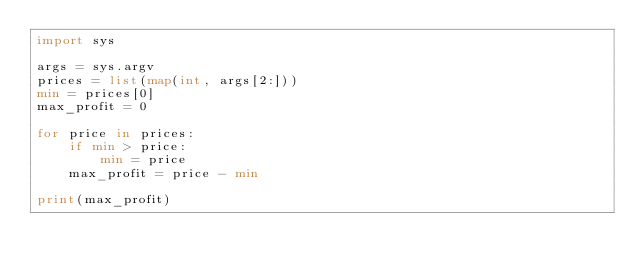<code> <loc_0><loc_0><loc_500><loc_500><_Python_>import sys
 
args = sys.argv
prices = list(map(int, args[2:]))
min = prices[0]
max_profit = 0

for price in prices:
    if min > price:
        min = price
    max_profit = price - min

print(max_profit)
</code> 